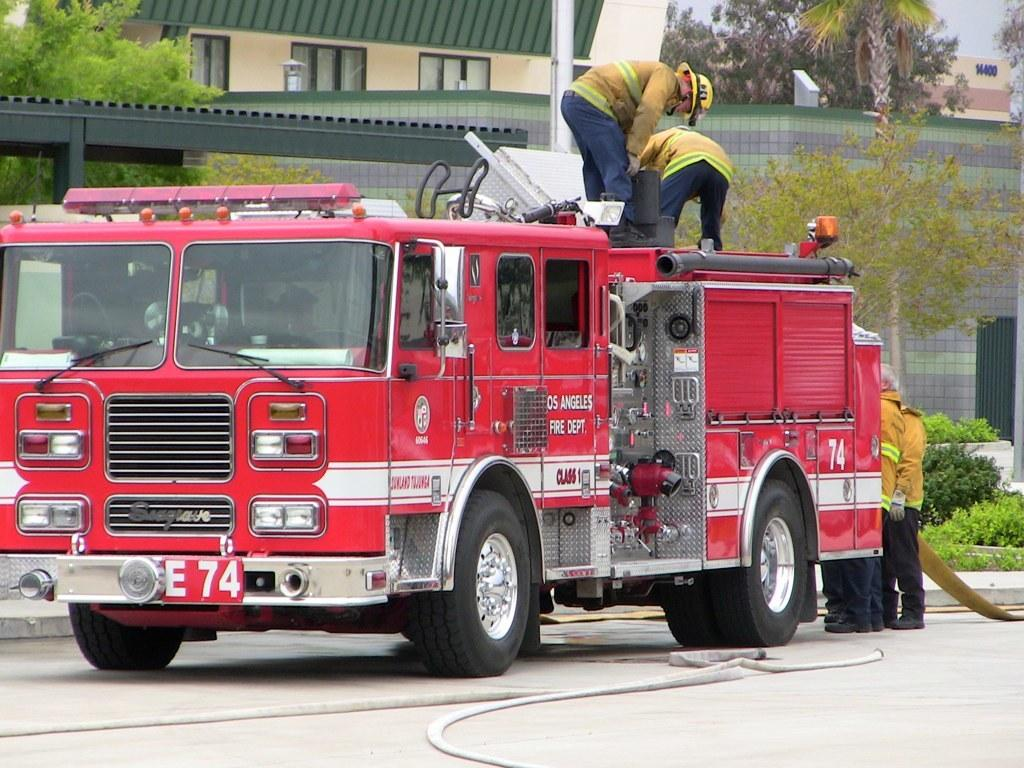What are the two persons doing in the image? The two persons are standing on a vehicle. What is happening behind the vehicle in the image? There are people standing on the road behind the vehicle. What can be seen in the distance in the image? There are buildings and trees in the background of the image. What is the plot of the story being told in the image? The image does not depict a story or plot; it is a static scene. 